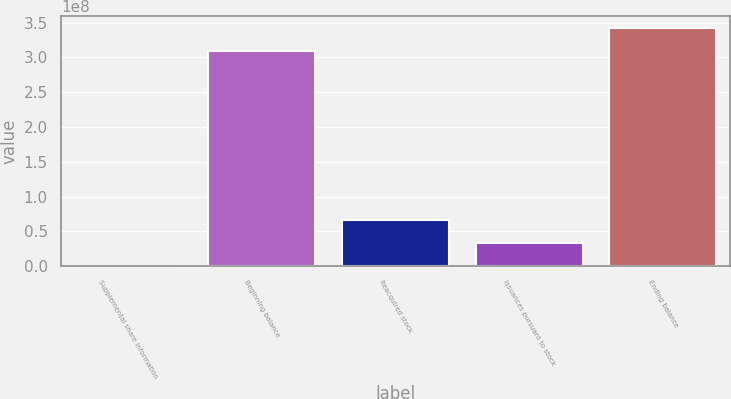<chart> <loc_0><loc_0><loc_500><loc_500><bar_chart><fcel>Supplemental share information<fcel>Beginning balance<fcel>Reacquired stock<fcel>Issuances pursuant to stock<fcel>Ending balance<nl><fcel>2015<fcel>3.08898e+08<fcel>6.69422e+07<fcel>3.34721e+07<fcel>3.42369e+08<nl></chart> 